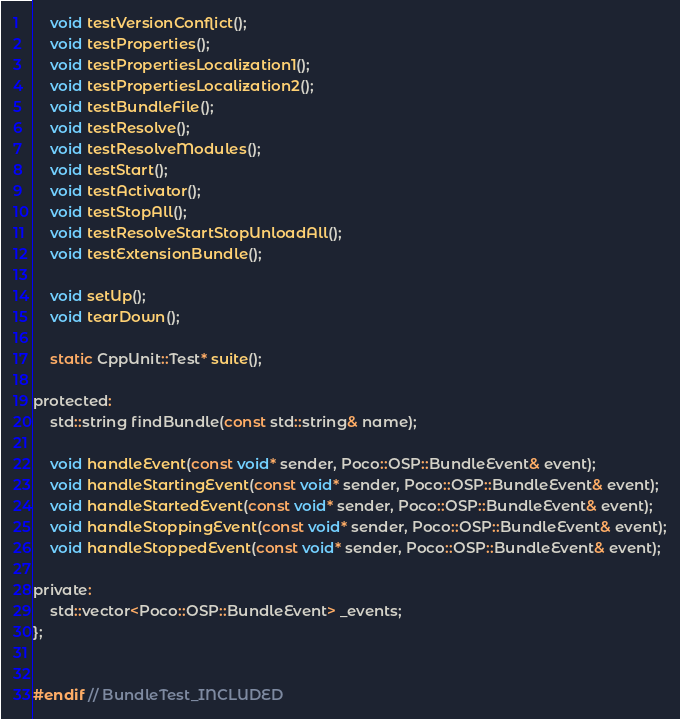<code> <loc_0><loc_0><loc_500><loc_500><_C_>	void testVersionConflict();
	void testProperties();
	void testPropertiesLocalization1();
	void testPropertiesLocalization2();
	void testBundleFile();
	void testResolve();
	void testResolveModules();
	void testStart();
	void testActivator();
	void testStopAll();
	void testResolveStartStopUnloadAll();
	void testExtensionBundle();

	void setUp();
	void tearDown();

	static CppUnit::Test* suite();

protected:
	std::string findBundle(const std::string& name);

	void handleEvent(const void* sender, Poco::OSP::BundleEvent& event);
	void handleStartingEvent(const void* sender, Poco::OSP::BundleEvent& event);
	void handleStartedEvent(const void* sender, Poco::OSP::BundleEvent& event);
	void handleStoppingEvent(const void* sender, Poco::OSP::BundleEvent& event);
	void handleStoppedEvent(const void* sender, Poco::OSP::BundleEvent& event);

private:
	std::vector<Poco::OSP::BundleEvent> _events;
};


#endif // BundleTest_INCLUDED
</code> 